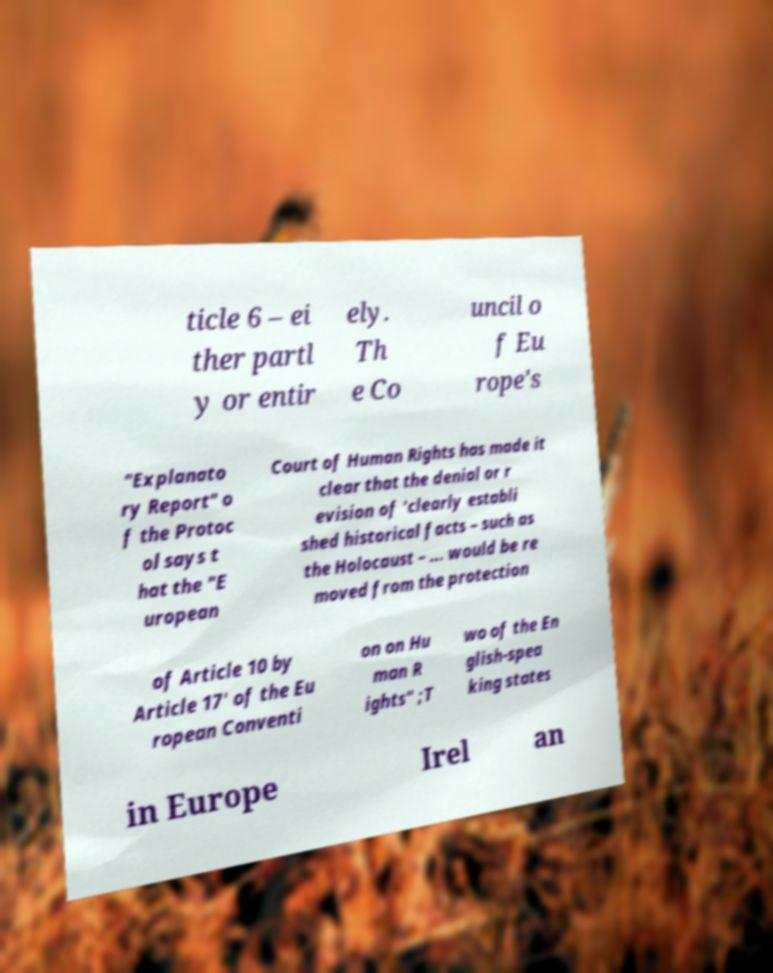Could you extract and type out the text from this image? ticle 6 – ei ther partl y or entir ely. Th e Co uncil o f Eu rope's "Explanato ry Report" o f the Protoc ol says t hat the "E uropean Court of Human Rights has made it clear that the denial or r evision of 'clearly establi shed historical facts – such as the Holocaust – ... would be re moved from the protection of Article 10 by Article 17' of the Eu ropean Conventi on on Hu man R ights" ;T wo of the En glish-spea king states in Europe Irel an 